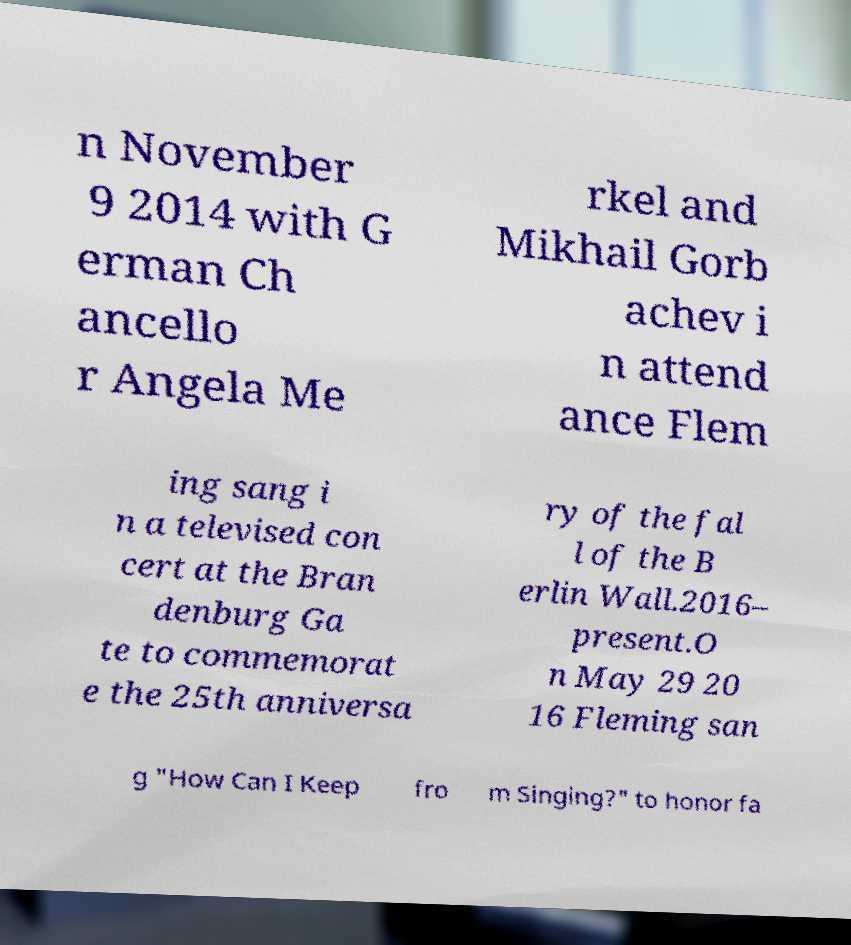What messages or text are displayed in this image? I need them in a readable, typed format. n November 9 2014 with G erman Ch ancello r Angela Me rkel and Mikhail Gorb achev i n attend ance Flem ing sang i n a televised con cert at the Bran denburg Ga te to commemorat e the 25th anniversa ry of the fal l of the B erlin Wall.2016– present.O n May 29 20 16 Fleming san g "How Can I Keep fro m Singing?" to honor fa 